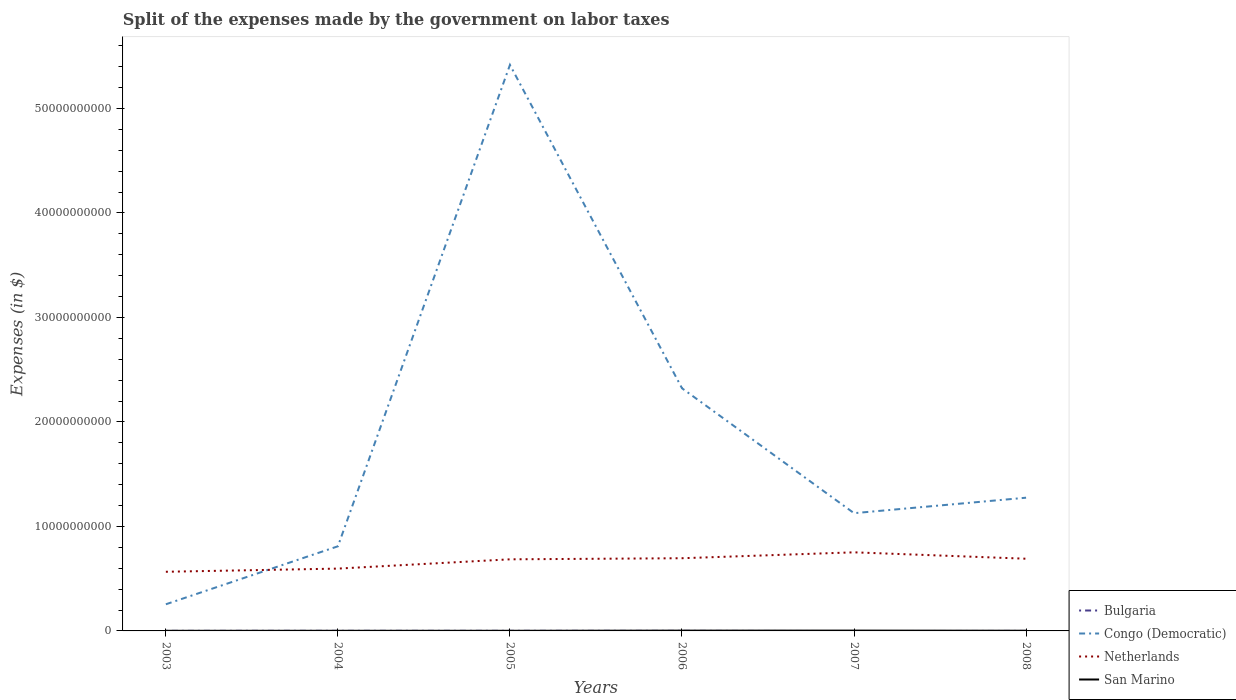How many different coloured lines are there?
Provide a succinct answer. 4. Does the line corresponding to Bulgaria intersect with the line corresponding to San Marino?
Provide a short and direct response. No. Is the number of lines equal to the number of legend labels?
Your response must be concise. No. Across all years, what is the maximum expenses made by the government on labor taxes in Bulgaria?
Offer a very short reply. 0. What is the total expenses made by the government on labor taxes in Netherlands in the graph?
Keep it short and to the point. 4.80e+07. What is the difference between the highest and the second highest expenses made by the government on labor taxes in Bulgaria?
Provide a short and direct response. 8.16e+06. Is the expenses made by the government on labor taxes in Congo (Democratic) strictly greater than the expenses made by the government on labor taxes in Bulgaria over the years?
Your answer should be compact. No. What is the difference between two consecutive major ticks on the Y-axis?
Make the answer very short. 1.00e+1. Are the values on the major ticks of Y-axis written in scientific E-notation?
Ensure brevity in your answer.  No. Does the graph contain any zero values?
Provide a succinct answer. Yes. Does the graph contain grids?
Provide a succinct answer. No. Where does the legend appear in the graph?
Your answer should be very brief. Bottom right. How many legend labels are there?
Your response must be concise. 4. What is the title of the graph?
Offer a terse response. Split of the expenses made by the government on labor taxes. Does "Swaziland" appear as one of the legend labels in the graph?
Your answer should be very brief. No. What is the label or title of the X-axis?
Provide a succinct answer. Years. What is the label or title of the Y-axis?
Offer a terse response. Expenses (in $). What is the Expenses (in $) in Bulgaria in 2003?
Your answer should be compact. 5.93e+06. What is the Expenses (in $) of Congo (Democratic) in 2003?
Make the answer very short. 2.55e+09. What is the Expenses (in $) of Netherlands in 2003?
Your answer should be very brief. 5.66e+09. What is the Expenses (in $) in San Marino in 2003?
Keep it short and to the point. 1.21e+07. What is the Expenses (in $) in Bulgaria in 2004?
Your response must be concise. 7.65e+06. What is the Expenses (in $) in Congo (Democratic) in 2004?
Your answer should be very brief. 8.10e+09. What is the Expenses (in $) in Netherlands in 2004?
Keep it short and to the point. 5.96e+09. What is the Expenses (in $) in San Marino in 2004?
Your answer should be compact. 1.28e+07. What is the Expenses (in $) of Bulgaria in 2005?
Make the answer very short. 8.16e+06. What is the Expenses (in $) of Congo (Democratic) in 2005?
Ensure brevity in your answer.  5.42e+1. What is the Expenses (in $) of Netherlands in 2005?
Your response must be concise. 6.85e+09. What is the Expenses (in $) of San Marino in 2005?
Make the answer very short. 1.40e+07. What is the Expenses (in $) of Bulgaria in 2006?
Provide a succinct answer. 5.75e+06. What is the Expenses (in $) of Congo (Democratic) in 2006?
Ensure brevity in your answer.  2.32e+1. What is the Expenses (in $) in Netherlands in 2006?
Provide a short and direct response. 6.96e+09. What is the Expenses (in $) in San Marino in 2006?
Provide a succinct answer. 2.84e+07. What is the Expenses (in $) in Congo (Democratic) in 2007?
Offer a terse response. 1.13e+1. What is the Expenses (in $) of Netherlands in 2007?
Provide a short and direct response. 7.52e+09. What is the Expenses (in $) of San Marino in 2007?
Provide a succinct answer. 3.20e+07. What is the Expenses (in $) of Bulgaria in 2008?
Ensure brevity in your answer.  6.49e+05. What is the Expenses (in $) of Congo (Democratic) in 2008?
Keep it short and to the point. 1.27e+1. What is the Expenses (in $) of Netherlands in 2008?
Provide a succinct answer. 6.91e+09. What is the Expenses (in $) of San Marino in 2008?
Give a very brief answer. 1.87e+07. Across all years, what is the maximum Expenses (in $) in Bulgaria?
Make the answer very short. 8.16e+06. Across all years, what is the maximum Expenses (in $) in Congo (Democratic)?
Offer a very short reply. 5.42e+1. Across all years, what is the maximum Expenses (in $) in Netherlands?
Keep it short and to the point. 7.52e+09. Across all years, what is the maximum Expenses (in $) of San Marino?
Give a very brief answer. 3.20e+07. Across all years, what is the minimum Expenses (in $) in Congo (Democratic)?
Offer a terse response. 2.55e+09. Across all years, what is the minimum Expenses (in $) in Netherlands?
Your answer should be compact. 5.66e+09. Across all years, what is the minimum Expenses (in $) in San Marino?
Your response must be concise. 1.21e+07. What is the total Expenses (in $) in Bulgaria in the graph?
Offer a terse response. 2.81e+07. What is the total Expenses (in $) in Congo (Democratic) in the graph?
Provide a succinct answer. 1.12e+11. What is the total Expenses (in $) in Netherlands in the graph?
Give a very brief answer. 3.99e+1. What is the total Expenses (in $) of San Marino in the graph?
Offer a terse response. 1.18e+08. What is the difference between the Expenses (in $) of Bulgaria in 2003 and that in 2004?
Ensure brevity in your answer.  -1.72e+06. What is the difference between the Expenses (in $) in Congo (Democratic) in 2003 and that in 2004?
Your answer should be compact. -5.55e+09. What is the difference between the Expenses (in $) in Netherlands in 2003 and that in 2004?
Your response must be concise. -3.03e+08. What is the difference between the Expenses (in $) in San Marino in 2003 and that in 2004?
Your answer should be very brief. -7.01e+05. What is the difference between the Expenses (in $) of Bulgaria in 2003 and that in 2005?
Your answer should be very brief. -2.23e+06. What is the difference between the Expenses (in $) in Congo (Democratic) in 2003 and that in 2005?
Make the answer very short. -5.16e+1. What is the difference between the Expenses (in $) in Netherlands in 2003 and that in 2005?
Keep it short and to the point. -1.19e+09. What is the difference between the Expenses (in $) of San Marino in 2003 and that in 2005?
Provide a short and direct response. -1.90e+06. What is the difference between the Expenses (in $) of Bulgaria in 2003 and that in 2006?
Provide a succinct answer. 1.81e+05. What is the difference between the Expenses (in $) of Congo (Democratic) in 2003 and that in 2006?
Your response must be concise. -2.07e+1. What is the difference between the Expenses (in $) in Netherlands in 2003 and that in 2006?
Give a very brief answer. -1.30e+09. What is the difference between the Expenses (in $) in San Marino in 2003 and that in 2006?
Make the answer very short. -1.63e+07. What is the difference between the Expenses (in $) of Congo (Democratic) in 2003 and that in 2007?
Provide a succinct answer. -8.72e+09. What is the difference between the Expenses (in $) of Netherlands in 2003 and that in 2007?
Offer a very short reply. -1.86e+09. What is the difference between the Expenses (in $) of San Marino in 2003 and that in 2007?
Provide a short and direct response. -1.99e+07. What is the difference between the Expenses (in $) of Bulgaria in 2003 and that in 2008?
Keep it short and to the point. 5.28e+06. What is the difference between the Expenses (in $) of Congo (Democratic) in 2003 and that in 2008?
Ensure brevity in your answer.  -1.02e+1. What is the difference between the Expenses (in $) of Netherlands in 2003 and that in 2008?
Your answer should be compact. -1.25e+09. What is the difference between the Expenses (in $) in San Marino in 2003 and that in 2008?
Offer a terse response. -6.58e+06. What is the difference between the Expenses (in $) of Bulgaria in 2004 and that in 2005?
Offer a very short reply. -5.08e+05. What is the difference between the Expenses (in $) in Congo (Democratic) in 2004 and that in 2005?
Your answer should be very brief. -4.61e+1. What is the difference between the Expenses (in $) in Netherlands in 2004 and that in 2005?
Offer a terse response. -8.88e+08. What is the difference between the Expenses (in $) in San Marino in 2004 and that in 2005?
Give a very brief answer. -1.20e+06. What is the difference between the Expenses (in $) in Bulgaria in 2004 and that in 2006?
Keep it short and to the point. 1.90e+06. What is the difference between the Expenses (in $) of Congo (Democratic) in 2004 and that in 2006?
Make the answer very short. -1.51e+1. What is the difference between the Expenses (in $) of Netherlands in 2004 and that in 2006?
Keep it short and to the point. -9.93e+08. What is the difference between the Expenses (in $) in San Marino in 2004 and that in 2006?
Ensure brevity in your answer.  -1.56e+07. What is the difference between the Expenses (in $) of Congo (Democratic) in 2004 and that in 2007?
Your response must be concise. -3.17e+09. What is the difference between the Expenses (in $) of Netherlands in 2004 and that in 2007?
Give a very brief answer. -1.56e+09. What is the difference between the Expenses (in $) of San Marino in 2004 and that in 2007?
Offer a very short reply. -1.92e+07. What is the difference between the Expenses (in $) of Bulgaria in 2004 and that in 2008?
Provide a short and direct response. 7.00e+06. What is the difference between the Expenses (in $) of Congo (Democratic) in 2004 and that in 2008?
Offer a very short reply. -4.65e+09. What is the difference between the Expenses (in $) in Netherlands in 2004 and that in 2008?
Your answer should be compact. -9.45e+08. What is the difference between the Expenses (in $) in San Marino in 2004 and that in 2008?
Your answer should be very brief. -5.88e+06. What is the difference between the Expenses (in $) of Bulgaria in 2005 and that in 2006?
Keep it short and to the point. 2.41e+06. What is the difference between the Expenses (in $) of Congo (Democratic) in 2005 and that in 2006?
Offer a terse response. 3.09e+1. What is the difference between the Expenses (in $) of Netherlands in 2005 and that in 2006?
Make the answer very short. -1.05e+08. What is the difference between the Expenses (in $) of San Marino in 2005 and that in 2006?
Ensure brevity in your answer.  -1.44e+07. What is the difference between the Expenses (in $) of Congo (Democratic) in 2005 and that in 2007?
Your answer should be very brief. 4.29e+1. What is the difference between the Expenses (in $) of Netherlands in 2005 and that in 2007?
Your answer should be very brief. -6.69e+08. What is the difference between the Expenses (in $) of San Marino in 2005 and that in 2007?
Your response must be concise. -1.80e+07. What is the difference between the Expenses (in $) in Bulgaria in 2005 and that in 2008?
Your answer should be compact. 7.51e+06. What is the difference between the Expenses (in $) of Congo (Democratic) in 2005 and that in 2008?
Provide a succinct answer. 4.14e+1. What is the difference between the Expenses (in $) of Netherlands in 2005 and that in 2008?
Ensure brevity in your answer.  -5.70e+07. What is the difference between the Expenses (in $) in San Marino in 2005 and that in 2008?
Provide a succinct answer. -4.68e+06. What is the difference between the Expenses (in $) of Congo (Democratic) in 2006 and that in 2007?
Offer a terse response. 1.20e+1. What is the difference between the Expenses (in $) of Netherlands in 2006 and that in 2007?
Make the answer very short. -5.64e+08. What is the difference between the Expenses (in $) in San Marino in 2006 and that in 2007?
Make the answer very short. -3.56e+06. What is the difference between the Expenses (in $) in Bulgaria in 2006 and that in 2008?
Your answer should be very brief. 5.10e+06. What is the difference between the Expenses (in $) of Congo (Democratic) in 2006 and that in 2008?
Provide a short and direct response. 1.05e+1. What is the difference between the Expenses (in $) of Netherlands in 2006 and that in 2008?
Your answer should be compact. 4.80e+07. What is the difference between the Expenses (in $) in San Marino in 2006 and that in 2008?
Provide a succinct answer. 9.73e+06. What is the difference between the Expenses (in $) of Congo (Democratic) in 2007 and that in 2008?
Your response must be concise. -1.48e+09. What is the difference between the Expenses (in $) in Netherlands in 2007 and that in 2008?
Make the answer very short. 6.12e+08. What is the difference between the Expenses (in $) of San Marino in 2007 and that in 2008?
Offer a very short reply. 1.33e+07. What is the difference between the Expenses (in $) of Bulgaria in 2003 and the Expenses (in $) of Congo (Democratic) in 2004?
Ensure brevity in your answer.  -8.09e+09. What is the difference between the Expenses (in $) in Bulgaria in 2003 and the Expenses (in $) in Netherlands in 2004?
Offer a terse response. -5.96e+09. What is the difference between the Expenses (in $) in Bulgaria in 2003 and the Expenses (in $) in San Marino in 2004?
Offer a terse response. -6.87e+06. What is the difference between the Expenses (in $) in Congo (Democratic) in 2003 and the Expenses (in $) in Netherlands in 2004?
Your answer should be compact. -3.41e+09. What is the difference between the Expenses (in $) of Congo (Democratic) in 2003 and the Expenses (in $) of San Marino in 2004?
Your response must be concise. 2.54e+09. What is the difference between the Expenses (in $) of Netherlands in 2003 and the Expenses (in $) of San Marino in 2004?
Offer a very short reply. 5.65e+09. What is the difference between the Expenses (in $) in Bulgaria in 2003 and the Expenses (in $) in Congo (Democratic) in 2005?
Your answer should be compact. -5.42e+1. What is the difference between the Expenses (in $) in Bulgaria in 2003 and the Expenses (in $) in Netherlands in 2005?
Keep it short and to the point. -6.85e+09. What is the difference between the Expenses (in $) of Bulgaria in 2003 and the Expenses (in $) of San Marino in 2005?
Ensure brevity in your answer.  -8.07e+06. What is the difference between the Expenses (in $) in Congo (Democratic) in 2003 and the Expenses (in $) in Netherlands in 2005?
Provide a succinct answer. -4.30e+09. What is the difference between the Expenses (in $) of Congo (Democratic) in 2003 and the Expenses (in $) of San Marino in 2005?
Your response must be concise. 2.54e+09. What is the difference between the Expenses (in $) of Netherlands in 2003 and the Expenses (in $) of San Marino in 2005?
Ensure brevity in your answer.  5.65e+09. What is the difference between the Expenses (in $) of Bulgaria in 2003 and the Expenses (in $) of Congo (Democratic) in 2006?
Ensure brevity in your answer.  -2.32e+1. What is the difference between the Expenses (in $) in Bulgaria in 2003 and the Expenses (in $) in Netherlands in 2006?
Provide a succinct answer. -6.95e+09. What is the difference between the Expenses (in $) in Bulgaria in 2003 and the Expenses (in $) in San Marino in 2006?
Give a very brief answer. -2.25e+07. What is the difference between the Expenses (in $) in Congo (Democratic) in 2003 and the Expenses (in $) in Netherlands in 2006?
Your answer should be compact. -4.41e+09. What is the difference between the Expenses (in $) of Congo (Democratic) in 2003 and the Expenses (in $) of San Marino in 2006?
Provide a succinct answer. 2.52e+09. What is the difference between the Expenses (in $) of Netherlands in 2003 and the Expenses (in $) of San Marino in 2006?
Your response must be concise. 5.63e+09. What is the difference between the Expenses (in $) of Bulgaria in 2003 and the Expenses (in $) of Congo (Democratic) in 2007?
Give a very brief answer. -1.13e+1. What is the difference between the Expenses (in $) of Bulgaria in 2003 and the Expenses (in $) of Netherlands in 2007?
Offer a terse response. -7.52e+09. What is the difference between the Expenses (in $) of Bulgaria in 2003 and the Expenses (in $) of San Marino in 2007?
Your response must be concise. -2.60e+07. What is the difference between the Expenses (in $) of Congo (Democratic) in 2003 and the Expenses (in $) of Netherlands in 2007?
Ensure brevity in your answer.  -4.97e+09. What is the difference between the Expenses (in $) in Congo (Democratic) in 2003 and the Expenses (in $) in San Marino in 2007?
Make the answer very short. 2.52e+09. What is the difference between the Expenses (in $) in Netherlands in 2003 and the Expenses (in $) in San Marino in 2007?
Offer a very short reply. 5.63e+09. What is the difference between the Expenses (in $) of Bulgaria in 2003 and the Expenses (in $) of Congo (Democratic) in 2008?
Provide a short and direct response. -1.27e+1. What is the difference between the Expenses (in $) of Bulgaria in 2003 and the Expenses (in $) of Netherlands in 2008?
Ensure brevity in your answer.  -6.90e+09. What is the difference between the Expenses (in $) in Bulgaria in 2003 and the Expenses (in $) in San Marino in 2008?
Offer a very short reply. -1.28e+07. What is the difference between the Expenses (in $) in Congo (Democratic) in 2003 and the Expenses (in $) in Netherlands in 2008?
Your answer should be compact. -4.36e+09. What is the difference between the Expenses (in $) in Congo (Democratic) in 2003 and the Expenses (in $) in San Marino in 2008?
Offer a terse response. 2.53e+09. What is the difference between the Expenses (in $) of Netherlands in 2003 and the Expenses (in $) of San Marino in 2008?
Your answer should be very brief. 5.64e+09. What is the difference between the Expenses (in $) in Bulgaria in 2004 and the Expenses (in $) in Congo (Democratic) in 2005?
Offer a terse response. -5.42e+1. What is the difference between the Expenses (in $) in Bulgaria in 2004 and the Expenses (in $) in Netherlands in 2005?
Provide a succinct answer. -6.84e+09. What is the difference between the Expenses (in $) of Bulgaria in 2004 and the Expenses (in $) of San Marino in 2005?
Keep it short and to the point. -6.34e+06. What is the difference between the Expenses (in $) of Congo (Democratic) in 2004 and the Expenses (in $) of Netherlands in 2005?
Your response must be concise. 1.25e+09. What is the difference between the Expenses (in $) of Congo (Democratic) in 2004 and the Expenses (in $) of San Marino in 2005?
Keep it short and to the point. 8.08e+09. What is the difference between the Expenses (in $) in Netherlands in 2004 and the Expenses (in $) in San Marino in 2005?
Keep it short and to the point. 5.95e+09. What is the difference between the Expenses (in $) of Bulgaria in 2004 and the Expenses (in $) of Congo (Democratic) in 2006?
Ensure brevity in your answer.  -2.32e+1. What is the difference between the Expenses (in $) of Bulgaria in 2004 and the Expenses (in $) of Netherlands in 2006?
Your answer should be very brief. -6.95e+09. What is the difference between the Expenses (in $) of Bulgaria in 2004 and the Expenses (in $) of San Marino in 2006?
Keep it short and to the point. -2.08e+07. What is the difference between the Expenses (in $) of Congo (Democratic) in 2004 and the Expenses (in $) of Netherlands in 2006?
Keep it short and to the point. 1.14e+09. What is the difference between the Expenses (in $) of Congo (Democratic) in 2004 and the Expenses (in $) of San Marino in 2006?
Offer a very short reply. 8.07e+09. What is the difference between the Expenses (in $) in Netherlands in 2004 and the Expenses (in $) in San Marino in 2006?
Offer a very short reply. 5.94e+09. What is the difference between the Expenses (in $) of Bulgaria in 2004 and the Expenses (in $) of Congo (Democratic) in 2007?
Give a very brief answer. -1.13e+1. What is the difference between the Expenses (in $) of Bulgaria in 2004 and the Expenses (in $) of Netherlands in 2007?
Offer a very short reply. -7.51e+09. What is the difference between the Expenses (in $) in Bulgaria in 2004 and the Expenses (in $) in San Marino in 2007?
Your answer should be compact. -2.43e+07. What is the difference between the Expenses (in $) in Congo (Democratic) in 2004 and the Expenses (in $) in Netherlands in 2007?
Ensure brevity in your answer.  5.78e+08. What is the difference between the Expenses (in $) in Congo (Democratic) in 2004 and the Expenses (in $) in San Marino in 2007?
Offer a very short reply. 8.07e+09. What is the difference between the Expenses (in $) in Netherlands in 2004 and the Expenses (in $) in San Marino in 2007?
Give a very brief answer. 5.93e+09. What is the difference between the Expenses (in $) in Bulgaria in 2004 and the Expenses (in $) in Congo (Democratic) in 2008?
Offer a terse response. -1.27e+1. What is the difference between the Expenses (in $) of Bulgaria in 2004 and the Expenses (in $) of Netherlands in 2008?
Your response must be concise. -6.90e+09. What is the difference between the Expenses (in $) in Bulgaria in 2004 and the Expenses (in $) in San Marino in 2008?
Provide a succinct answer. -1.10e+07. What is the difference between the Expenses (in $) in Congo (Democratic) in 2004 and the Expenses (in $) in Netherlands in 2008?
Your answer should be very brief. 1.19e+09. What is the difference between the Expenses (in $) of Congo (Democratic) in 2004 and the Expenses (in $) of San Marino in 2008?
Offer a very short reply. 8.08e+09. What is the difference between the Expenses (in $) in Netherlands in 2004 and the Expenses (in $) in San Marino in 2008?
Provide a succinct answer. 5.95e+09. What is the difference between the Expenses (in $) of Bulgaria in 2005 and the Expenses (in $) of Congo (Democratic) in 2006?
Offer a very short reply. -2.32e+1. What is the difference between the Expenses (in $) in Bulgaria in 2005 and the Expenses (in $) in Netherlands in 2006?
Offer a terse response. -6.95e+09. What is the difference between the Expenses (in $) of Bulgaria in 2005 and the Expenses (in $) of San Marino in 2006?
Offer a very short reply. -2.02e+07. What is the difference between the Expenses (in $) of Congo (Democratic) in 2005 and the Expenses (in $) of Netherlands in 2006?
Your answer should be very brief. 4.72e+1. What is the difference between the Expenses (in $) of Congo (Democratic) in 2005 and the Expenses (in $) of San Marino in 2006?
Offer a terse response. 5.41e+1. What is the difference between the Expenses (in $) in Netherlands in 2005 and the Expenses (in $) in San Marino in 2006?
Offer a terse response. 6.82e+09. What is the difference between the Expenses (in $) of Bulgaria in 2005 and the Expenses (in $) of Congo (Democratic) in 2007?
Your answer should be compact. -1.13e+1. What is the difference between the Expenses (in $) in Bulgaria in 2005 and the Expenses (in $) in Netherlands in 2007?
Your answer should be very brief. -7.51e+09. What is the difference between the Expenses (in $) in Bulgaria in 2005 and the Expenses (in $) in San Marino in 2007?
Your response must be concise. -2.38e+07. What is the difference between the Expenses (in $) of Congo (Democratic) in 2005 and the Expenses (in $) of Netherlands in 2007?
Keep it short and to the point. 4.66e+1. What is the difference between the Expenses (in $) of Congo (Democratic) in 2005 and the Expenses (in $) of San Marino in 2007?
Give a very brief answer. 5.41e+1. What is the difference between the Expenses (in $) of Netherlands in 2005 and the Expenses (in $) of San Marino in 2007?
Your response must be concise. 6.82e+09. What is the difference between the Expenses (in $) of Bulgaria in 2005 and the Expenses (in $) of Congo (Democratic) in 2008?
Your answer should be compact. -1.27e+1. What is the difference between the Expenses (in $) in Bulgaria in 2005 and the Expenses (in $) in Netherlands in 2008?
Give a very brief answer. -6.90e+09. What is the difference between the Expenses (in $) in Bulgaria in 2005 and the Expenses (in $) in San Marino in 2008?
Provide a short and direct response. -1.05e+07. What is the difference between the Expenses (in $) of Congo (Democratic) in 2005 and the Expenses (in $) of Netherlands in 2008?
Give a very brief answer. 4.73e+1. What is the difference between the Expenses (in $) in Congo (Democratic) in 2005 and the Expenses (in $) in San Marino in 2008?
Provide a succinct answer. 5.41e+1. What is the difference between the Expenses (in $) in Netherlands in 2005 and the Expenses (in $) in San Marino in 2008?
Give a very brief answer. 6.83e+09. What is the difference between the Expenses (in $) of Bulgaria in 2006 and the Expenses (in $) of Congo (Democratic) in 2007?
Provide a succinct answer. -1.13e+1. What is the difference between the Expenses (in $) of Bulgaria in 2006 and the Expenses (in $) of Netherlands in 2007?
Provide a succinct answer. -7.52e+09. What is the difference between the Expenses (in $) in Bulgaria in 2006 and the Expenses (in $) in San Marino in 2007?
Your answer should be compact. -2.62e+07. What is the difference between the Expenses (in $) of Congo (Democratic) in 2006 and the Expenses (in $) of Netherlands in 2007?
Offer a very short reply. 1.57e+1. What is the difference between the Expenses (in $) in Congo (Democratic) in 2006 and the Expenses (in $) in San Marino in 2007?
Make the answer very short. 2.32e+1. What is the difference between the Expenses (in $) in Netherlands in 2006 and the Expenses (in $) in San Marino in 2007?
Your answer should be very brief. 6.93e+09. What is the difference between the Expenses (in $) of Bulgaria in 2006 and the Expenses (in $) of Congo (Democratic) in 2008?
Keep it short and to the point. -1.27e+1. What is the difference between the Expenses (in $) in Bulgaria in 2006 and the Expenses (in $) in Netherlands in 2008?
Provide a short and direct response. -6.90e+09. What is the difference between the Expenses (in $) of Bulgaria in 2006 and the Expenses (in $) of San Marino in 2008?
Offer a terse response. -1.29e+07. What is the difference between the Expenses (in $) in Congo (Democratic) in 2006 and the Expenses (in $) in Netherlands in 2008?
Ensure brevity in your answer.  1.63e+1. What is the difference between the Expenses (in $) in Congo (Democratic) in 2006 and the Expenses (in $) in San Marino in 2008?
Provide a succinct answer. 2.32e+1. What is the difference between the Expenses (in $) of Netherlands in 2006 and the Expenses (in $) of San Marino in 2008?
Keep it short and to the point. 6.94e+09. What is the difference between the Expenses (in $) in Congo (Democratic) in 2007 and the Expenses (in $) in Netherlands in 2008?
Keep it short and to the point. 4.36e+09. What is the difference between the Expenses (in $) of Congo (Democratic) in 2007 and the Expenses (in $) of San Marino in 2008?
Your response must be concise. 1.12e+1. What is the difference between the Expenses (in $) in Netherlands in 2007 and the Expenses (in $) in San Marino in 2008?
Keep it short and to the point. 7.50e+09. What is the average Expenses (in $) of Bulgaria per year?
Your answer should be compact. 4.69e+06. What is the average Expenses (in $) in Congo (Democratic) per year?
Your answer should be very brief. 1.87e+1. What is the average Expenses (in $) of Netherlands per year?
Give a very brief answer. 6.64e+09. What is the average Expenses (in $) of San Marino per year?
Your response must be concise. 1.97e+07. In the year 2003, what is the difference between the Expenses (in $) of Bulgaria and Expenses (in $) of Congo (Democratic)?
Your response must be concise. -2.54e+09. In the year 2003, what is the difference between the Expenses (in $) of Bulgaria and Expenses (in $) of Netherlands?
Your answer should be very brief. -5.66e+09. In the year 2003, what is the difference between the Expenses (in $) of Bulgaria and Expenses (in $) of San Marino?
Give a very brief answer. -6.17e+06. In the year 2003, what is the difference between the Expenses (in $) in Congo (Democratic) and Expenses (in $) in Netherlands?
Your response must be concise. -3.11e+09. In the year 2003, what is the difference between the Expenses (in $) of Congo (Democratic) and Expenses (in $) of San Marino?
Your answer should be compact. 2.54e+09. In the year 2003, what is the difference between the Expenses (in $) of Netherlands and Expenses (in $) of San Marino?
Your response must be concise. 5.65e+09. In the year 2004, what is the difference between the Expenses (in $) in Bulgaria and Expenses (in $) in Congo (Democratic)?
Your answer should be compact. -8.09e+09. In the year 2004, what is the difference between the Expenses (in $) in Bulgaria and Expenses (in $) in Netherlands?
Keep it short and to the point. -5.96e+09. In the year 2004, what is the difference between the Expenses (in $) in Bulgaria and Expenses (in $) in San Marino?
Provide a short and direct response. -5.15e+06. In the year 2004, what is the difference between the Expenses (in $) in Congo (Democratic) and Expenses (in $) in Netherlands?
Keep it short and to the point. 2.13e+09. In the year 2004, what is the difference between the Expenses (in $) in Congo (Democratic) and Expenses (in $) in San Marino?
Provide a short and direct response. 8.09e+09. In the year 2004, what is the difference between the Expenses (in $) in Netherlands and Expenses (in $) in San Marino?
Your response must be concise. 5.95e+09. In the year 2005, what is the difference between the Expenses (in $) in Bulgaria and Expenses (in $) in Congo (Democratic)?
Make the answer very short. -5.42e+1. In the year 2005, what is the difference between the Expenses (in $) in Bulgaria and Expenses (in $) in Netherlands?
Offer a terse response. -6.84e+09. In the year 2005, what is the difference between the Expenses (in $) of Bulgaria and Expenses (in $) of San Marino?
Offer a terse response. -5.84e+06. In the year 2005, what is the difference between the Expenses (in $) of Congo (Democratic) and Expenses (in $) of Netherlands?
Your answer should be very brief. 4.73e+1. In the year 2005, what is the difference between the Expenses (in $) of Congo (Democratic) and Expenses (in $) of San Marino?
Provide a short and direct response. 5.42e+1. In the year 2005, what is the difference between the Expenses (in $) in Netherlands and Expenses (in $) in San Marino?
Keep it short and to the point. 6.84e+09. In the year 2006, what is the difference between the Expenses (in $) in Bulgaria and Expenses (in $) in Congo (Democratic)?
Make the answer very short. -2.32e+1. In the year 2006, what is the difference between the Expenses (in $) in Bulgaria and Expenses (in $) in Netherlands?
Provide a short and direct response. -6.95e+09. In the year 2006, what is the difference between the Expenses (in $) of Bulgaria and Expenses (in $) of San Marino?
Offer a very short reply. -2.27e+07. In the year 2006, what is the difference between the Expenses (in $) in Congo (Democratic) and Expenses (in $) in Netherlands?
Make the answer very short. 1.63e+1. In the year 2006, what is the difference between the Expenses (in $) of Congo (Democratic) and Expenses (in $) of San Marino?
Ensure brevity in your answer.  2.32e+1. In the year 2006, what is the difference between the Expenses (in $) in Netherlands and Expenses (in $) in San Marino?
Your answer should be compact. 6.93e+09. In the year 2007, what is the difference between the Expenses (in $) in Congo (Democratic) and Expenses (in $) in Netherlands?
Offer a terse response. 3.75e+09. In the year 2007, what is the difference between the Expenses (in $) in Congo (Democratic) and Expenses (in $) in San Marino?
Make the answer very short. 1.12e+1. In the year 2007, what is the difference between the Expenses (in $) of Netherlands and Expenses (in $) of San Marino?
Keep it short and to the point. 7.49e+09. In the year 2008, what is the difference between the Expenses (in $) of Bulgaria and Expenses (in $) of Congo (Democratic)?
Your answer should be very brief. -1.27e+1. In the year 2008, what is the difference between the Expenses (in $) of Bulgaria and Expenses (in $) of Netherlands?
Provide a short and direct response. -6.91e+09. In the year 2008, what is the difference between the Expenses (in $) of Bulgaria and Expenses (in $) of San Marino?
Provide a short and direct response. -1.80e+07. In the year 2008, what is the difference between the Expenses (in $) of Congo (Democratic) and Expenses (in $) of Netherlands?
Provide a short and direct response. 5.84e+09. In the year 2008, what is the difference between the Expenses (in $) of Congo (Democratic) and Expenses (in $) of San Marino?
Give a very brief answer. 1.27e+1. In the year 2008, what is the difference between the Expenses (in $) of Netherlands and Expenses (in $) of San Marino?
Offer a very short reply. 6.89e+09. What is the ratio of the Expenses (in $) of Bulgaria in 2003 to that in 2004?
Give a very brief answer. 0.77. What is the ratio of the Expenses (in $) of Congo (Democratic) in 2003 to that in 2004?
Offer a very short reply. 0.31. What is the ratio of the Expenses (in $) of Netherlands in 2003 to that in 2004?
Ensure brevity in your answer.  0.95. What is the ratio of the Expenses (in $) in San Marino in 2003 to that in 2004?
Offer a terse response. 0.95. What is the ratio of the Expenses (in $) in Bulgaria in 2003 to that in 2005?
Your answer should be compact. 0.73. What is the ratio of the Expenses (in $) in Congo (Democratic) in 2003 to that in 2005?
Your answer should be compact. 0.05. What is the ratio of the Expenses (in $) of Netherlands in 2003 to that in 2005?
Your response must be concise. 0.83. What is the ratio of the Expenses (in $) in San Marino in 2003 to that in 2005?
Give a very brief answer. 0.86. What is the ratio of the Expenses (in $) in Bulgaria in 2003 to that in 2006?
Provide a succinct answer. 1.03. What is the ratio of the Expenses (in $) of Congo (Democratic) in 2003 to that in 2006?
Your response must be concise. 0.11. What is the ratio of the Expenses (in $) in Netherlands in 2003 to that in 2006?
Provide a short and direct response. 0.81. What is the ratio of the Expenses (in $) of San Marino in 2003 to that in 2006?
Provide a short and direct response. 0.43. What is the ratio of the Expenses (in $) of Congo (Democratic) in 2003 to that in 2007?
Keep it short and to the point. 0.23. What is the ratio of the Expenses (in $) of Netherlands in 2003 to that in 2007?
Your answer should be compact. 0.75. What is the ratio of the Expenses (in $) in San Marino in 2003 to that in 2007?
Give a very brief answer. 0.38. What is the ratio of the Expenses (in $) in Bulgaria in 2003 to that in 2008?
Keep it short and to the point. 9.13. What is the ratio of the Expenses (in $) of Congo (Democratic) in 2003 to that in 2008?
Ensure brevity in your answer.  0.2. What is the ratio of the Expenses (in $) of Netherlands in 2003 to that in 2008?
Make the answer very short. 0.82. What is the ratio of the Expenses (in $) in San Marino in 2003 to that in 2008?
Give a very brief answer. 0.65. What is the ratio of the Expenses (in $) in Bulgaria in 2004 to that in 2005?
Make the answer very short. 0.94. What is the ratio of the Expenses (in $) in Congo (Democratic) in 2004 to that in 2005?
Offer a terse response. 0.15. What is the ratio of the Expenses (in $) in Netherlands in 2004 to that in 2005?
Ensure brevity in your answer.  0.87. What is the ratio of the Expenses (in $) of San Marino in 2004 to that in 2005?
Offer a terse response. 0.91. What is the ratio of the Expenses (in $) of Bulgaria in 2004 to that in 2006?
Make the answer very short. 1.33. What is the ratio of the Expenses (in $) of Congo (Democratic) in 2004 to that in 2006?
Offer a very short reply. 0.35. What is the ratio of the Expenses (in $) of Netherlands in 2004 to that in 2006?
Make the answer very short. 0.86. What is the ratio of the Expenses (in $) in San Marino in 2004 to that in 2006?
Offer a very short reply. 0.45. What is the ratio of the Expenses (in $) of Congo (Democratic) in 2004 to that in 2007?
Keep it short and to the point. 0.72. What is the ratio of the Expenses (in $) of Netherlands in 2004 to that in 2007?
Give a very brief answer. 0.79. What is the ratio of the Expenses (in $) in San Marino in 2004 to that in 2007?
Keep it short and to the point. 0.4. What is the ratio of the Expenses (in $) in Bulgaria in 2004 to that in 2008?
Provide a short and direct response. 11.79. What is the ratio of the Expenses (in $) in Congo (Democratic) in 2004 to that in 2008?
Provide a short and direct response. 0.64. What is the ratio of the Expenses (in $) in Netherlands in 2004 to that in 2008?
Ensure brevity in your answer.  0.86. What is the ratio of the Expenses (in $) of San Marino in 2004 to that in 2008?
Your answer should be very brief. 0.69. What is the ratio of the Expenses (in $) of Bulgaria in 2005 to that in 2006?
Keep it short and to the point. 1.42. What is the ratio of the Expenses (in $) in Congo (Democratic) in 2005 to that in 2006?
Offer a very short reply. 2.33. What is the ratio of the Expenses (in $) of Netherlands in 2005 to that in 2006?
Ensure brevity in your answer.  0.98. What is the ratio of the Expenses (in $) of San Marino in 2005 to that in 2006?
Offer a very short reply. 0.49. What is the ratio of the Expenses (in $) of Congo (Democratic) in 2005 to that in 2007?
Give a very brief answer. 4.81. What is the ratio of the Expenses (in $) in Netherlands in 2005 to that in 2007?
Keep it short and to the point. 0.91. What is the ratio of the Expenses (in $) of San Marino in 2005 to that in 2007?
Provide a short and direct response. 0.44. What is the ratio of the Expenses (in $) in Bulgaria in 2005 to that in 2008?
Offer a terse response. 12.57. What is the ratio of the Expenses (in $) of Congo (Democratic) in 2005 to that in 2008?
Ensure brevity in your answer.  4.25. What is the ratio of the Expenses (in $) of Netherlands in 2005 to that in 2008?
Provide a short and direct response. 0.99. What is the ratio of the Expenses (in $) in San Marino in 2005 to that in 2008?
Your answer should be very brief. 0.75. What is the ratio of the Expenses (in $) in Congo (Democratic) in 2006 to that in 2007?
Offer a terse response. 2.06. What is the ratio of the Expenses (in $) of Netherlands in 2006 to that in 2007?
Your answer should be compact. 0.93. What is the ratio of the Expenses (in $) in San Marino in 2006 to that in 2007?
Make the answer very short. 0.89. What is the ratio of the Expenses (in $) in Bulgaria in 2006 to that in 2008?
Offer a terse response. 8.86. What is the ratio of the Expenses (in $) in Congo (Democratic) in 2006 to that in 2008?
Offer a terse response. 1.82. What is the ratio of the Expenses (in $) of Netherlands in 2006 to that in 2008?
Make the answer very short. 1.01. What is the ratio of the Expenses (in $) in San Marino in 2006 to that in 2008?
Keep it short and to the point. 1.52. What is the ratio of the Expenses (in $) in Congo (Democratic) in 2007 to that in 2008?
Provide a short and direct response. 0.88. What is the ratio of the Expenses (in $) in Netherlands in 2007 to that in 2008?
Provide a short and direct response. 1.09. What is the ratio of the Expenses (in $) in San Marino in 2007 to that in 2008?
Keep it short and to the point. 1.71. What is the difference between the highest and the second highest Expenses (in $) of Bulgaria?
Provide a short and direct response. 5.08e+05. What is the difference between the highest and the second highest Expenses (in $) in Congo (Democratic)?
Give a very brief answer. 3.09e+1. What is the difference between the highest and the second highest Expenses (in $) of Netherlands?
Offer a very short reply. 5.64e+08. What is the difference between the highest and the second highest Expenses (in $) of San Marino?
Provide a succinct answer. 3.56e+06. What is the difference between the highest and the lowest Expenses (in $) of Bulgaria?
Your answer should be very brief. 8.16e+06. What is the difference between the highest and the lowest Expenses (in $) of Congo (Democratic)?
Provide a succinct answer. 5.16e+1. What is the difference between the highest and the lowest Expenses (in $) of Netherlands?
Your response must be concise. 1.86e+09. What is the difference between the highest and the lowest Expenses (in $) in San Marino?
Your answer should be compact. 1.99e+07. 